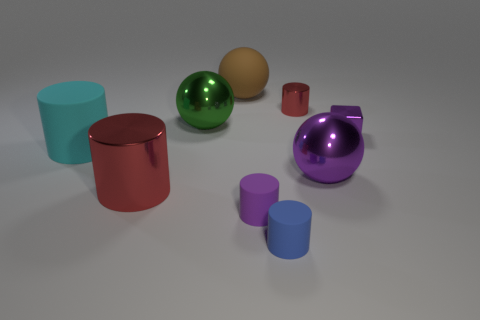How many green things have the same material as the big brown ball?
Keep it short and to the point. 0. Does the metallic cylinder that is in front of the cyan object have the same size as the big purple object?
Offer a very short reply. Yes. There is a matte cylinder that is the same size as the matte sphere; what is its color?
Your response must be concise. Cyan. There is a metal cube; what number of purple rubber objects are on the right side of it?
Provide a succinct answer. 0. Are any yellow objects visible?
Offer a terse response. No. What size is the sphere that is right of the red thing behind the big rubber object that is in front of the green metallic ball?
Keep it short and to the point. Large. How many other things are the same size as the brown thing?
Provide a succinct answer. 4. There is a metallic ball to the left of the brown rubber sphere; what size is it?
Keep it short and to the point. Large. Are there any other things that are the same color as the tiny metallic cube?
Your response must be concise. Yes. Is the material of the large object that is in front of the purple ball the same as the big brown object?
Provide a short and direct response. No. 